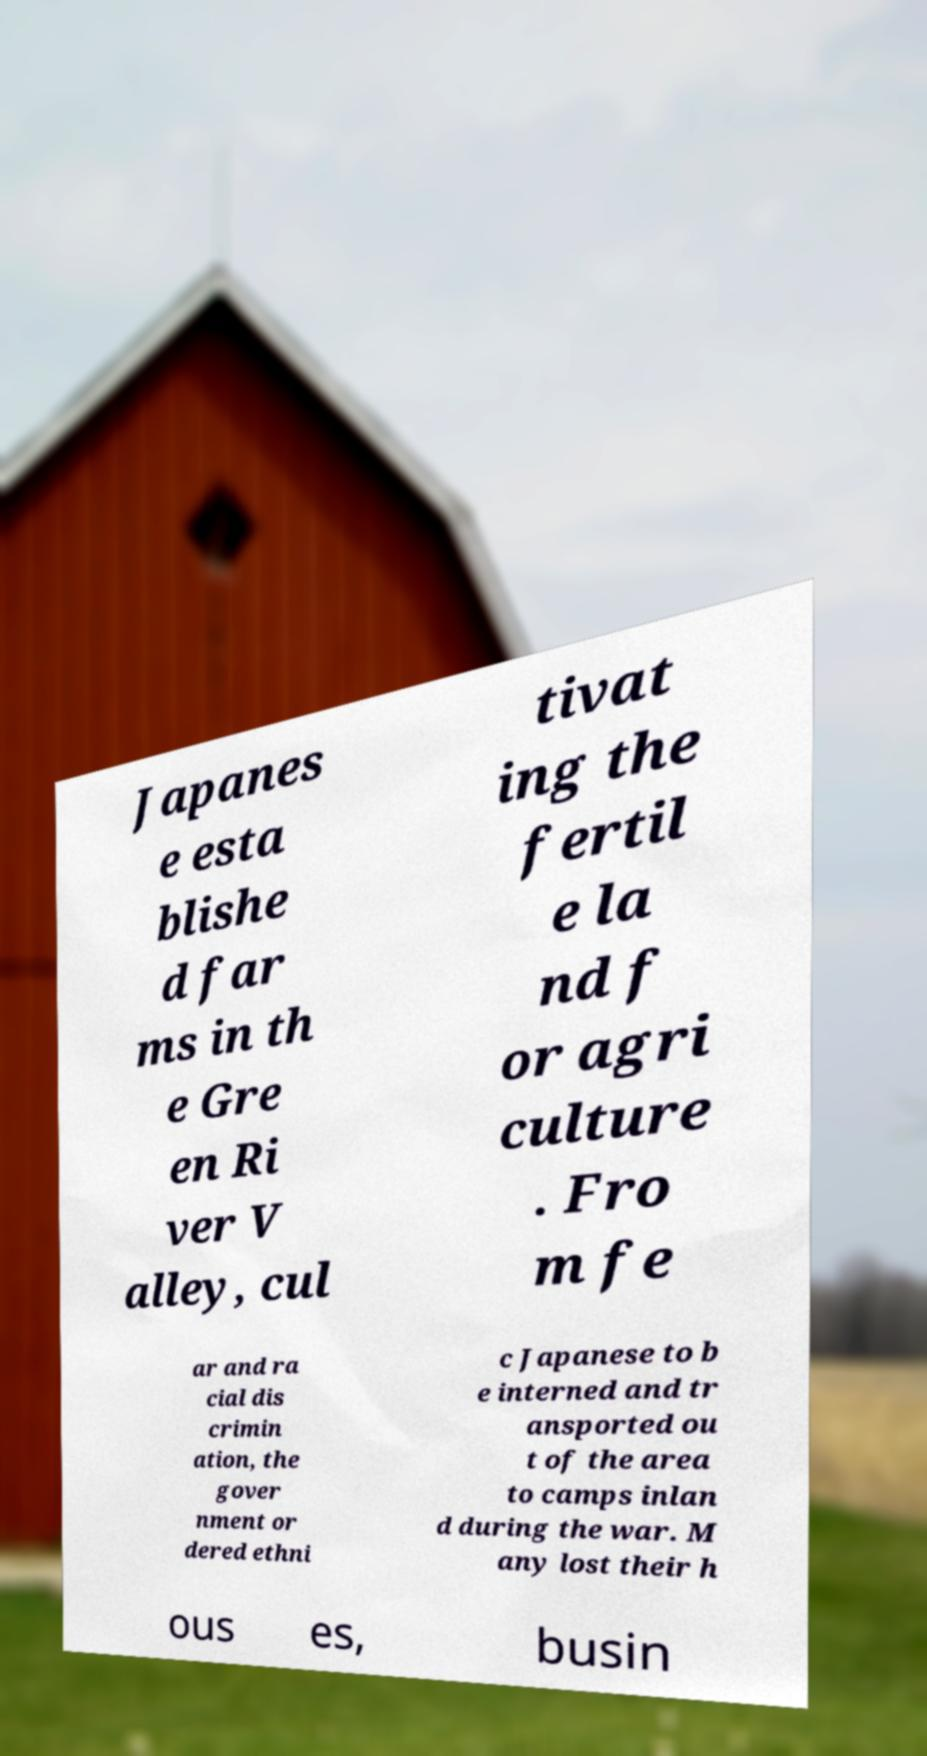Can you accurately transcribe the text from the provided image for me? Japanes e esta blishe d far ms in th e Gre en Ri ver V alley, cul tivat ing the fertil e la nd f or agri culture . Fro m fe ar and ra cial dis crimin ation, the gover nment or dered ethni c Japanese to b e interned and tr ansported ou t of the area to camps inlan d during the war. M any lost their h ous es, busin 